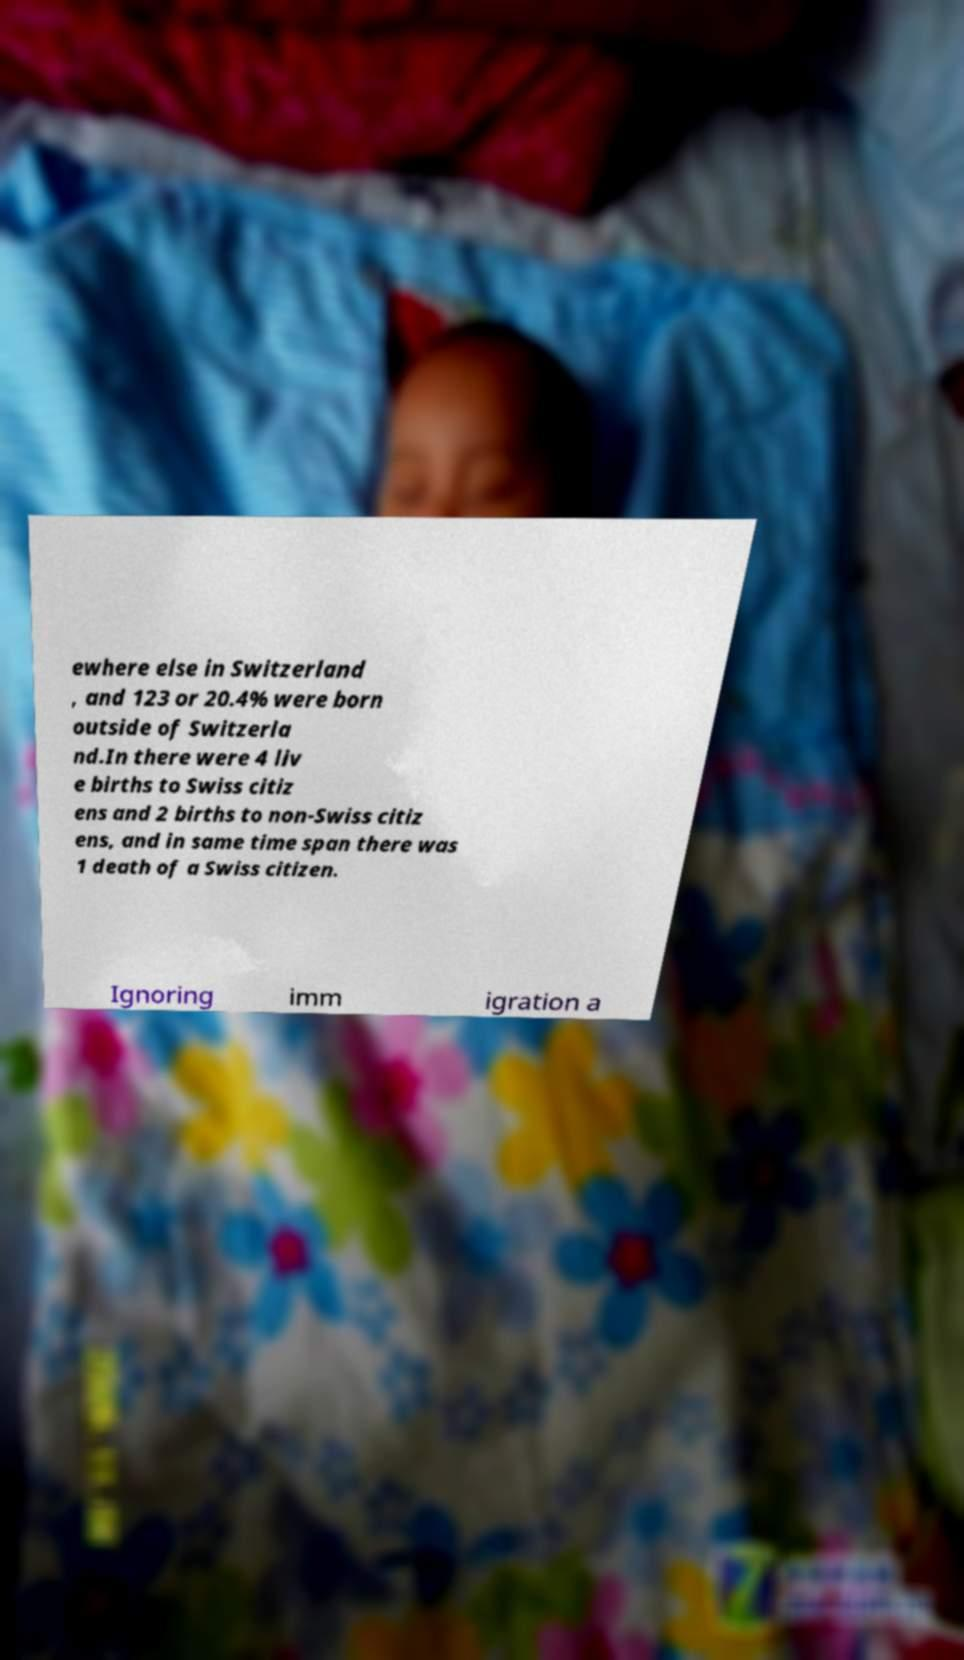For documentation purposes, I need the text within this image transcribed. Could you provide that? ewhere else in Switzerland , and 123 or 20.4% were born outside of Switzerla nd.In there were 4 liv e births to Swiss citiz ens and 2 births to non-Swiss citiz ens, and in same time span there was 1 death of a Swiss citizen. Ignoring imm igration a 